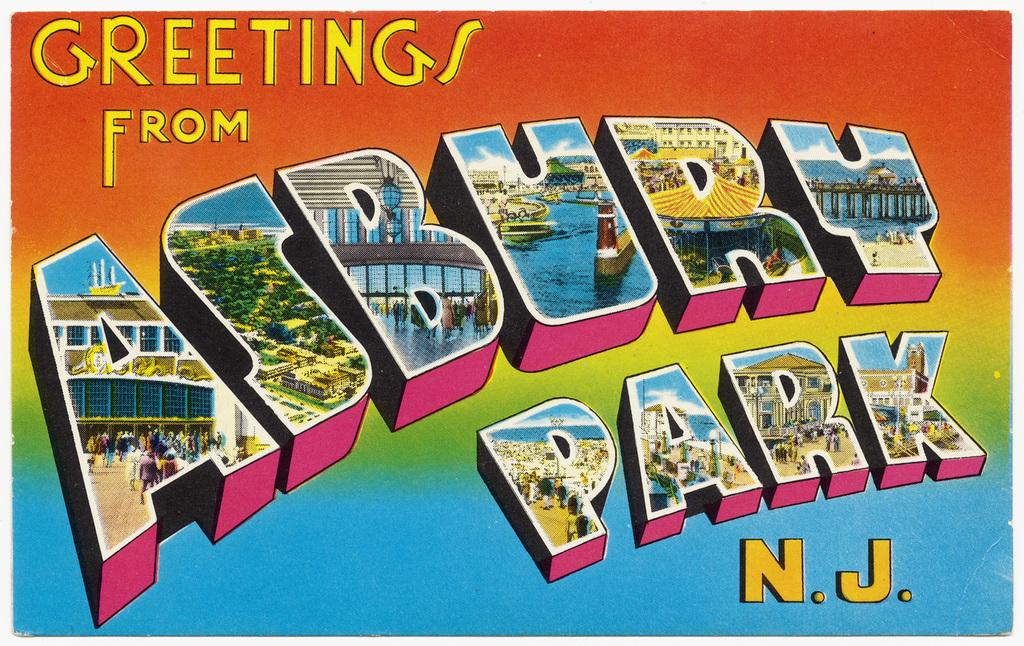Provide a one-sentence caption for the provided image. A greeting card from the Asbury Park with different colors and the letters with parts of the landscape of the park. 